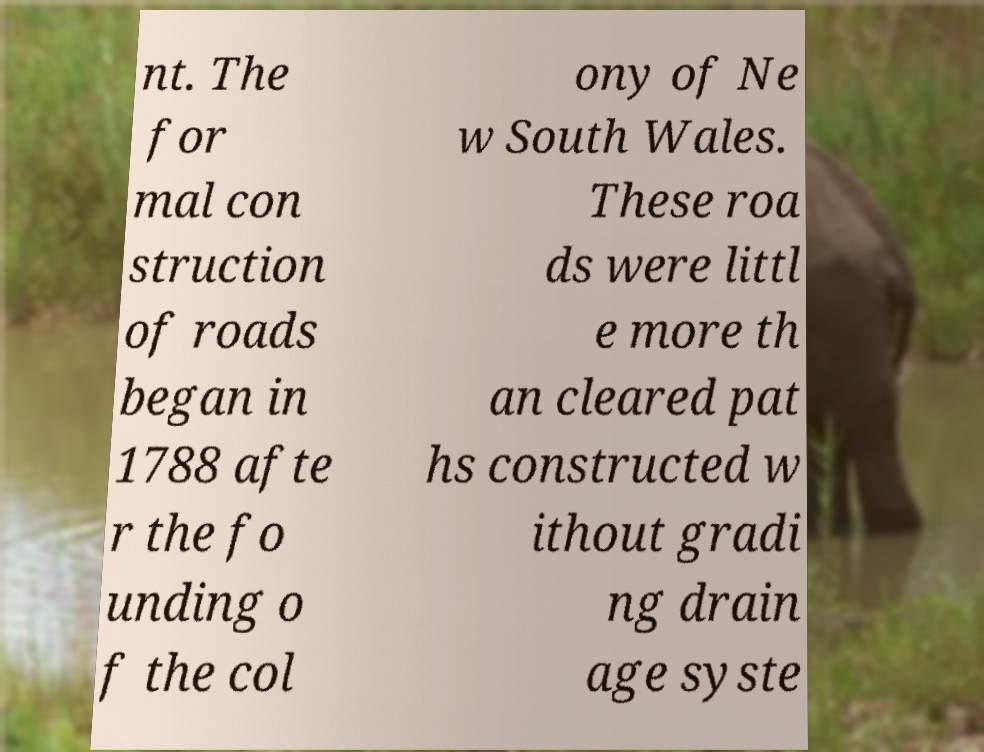Could you assist in decoding the text presented in this image and type it out clearly? nt. The for mal con struction of roads began in 1788 afte r the fo unding o f the col ony of Ne w South Wales. These roa ds were littl e more th an cleared pat hs constructed w ithout gradi ng drain age syste 